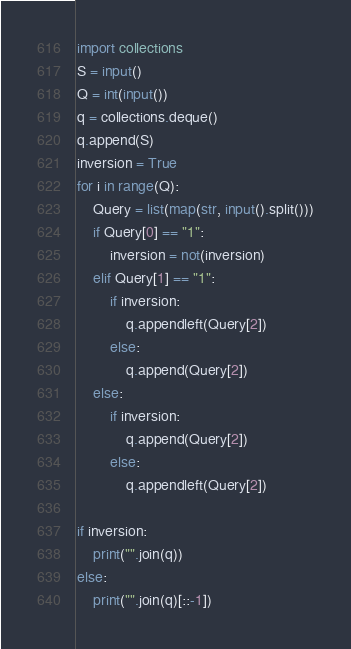<code> <loc_0><loc_0><loc_500><loc_500><_Python_>import collections
S = input()
Q = int(input())
q = collections.deque()
q.append(S)
inversion = True
for i in range(Q):
    Query = list(map(str, input().split()))
    if Query[0] == "1":
        inversion = not(inversion)
    elif Query[1] == "1":
        if inversion:
            q.appendleft(Query[2])
        else:
            q.append(Query[2])
    else:
        if inversion:
            q.append(Query[2])
        else:
            q.appendleft(Query[2])

if inversion:
    print("".join(q))
else:
    print("".join(q)[::-1])
</code> 